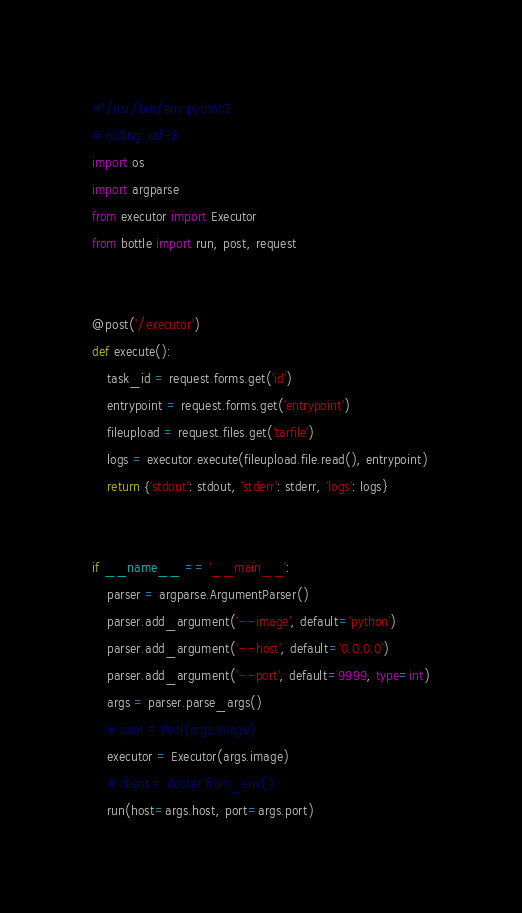Convert code to text. <code><loc_0><loc_0><loc_500><loc_500><_Python_>#!/usr/bin/env python3
# coding: utf-8
import os
import argparse
from executor import Executor
from bottle import run, post, request


@post('/executor')
def execute():
    task_id = request.forms.get('id')
    entrypoint = request.forms.get('entrypoint')
    fileupload = request.files.get('tarfile')
    logs = executor.execute(fileupload.file.read(), entrypoint)
    return {'stdout': stdout, 'stderr': stderr, 'logs': logs}


if __name__ == '__main__':
    parser = argparse.ArgumentParser()
    parser.add_argument('--image', default='python')
    parser.add_argument('--host', default='0.0.0.0')
    parser.add_argument('--port', default=9999, type=int)
    args = parser.parse_args()
    # pool = Pool(args.image)
    executor = Executor(args.image)
    # client = docker.from_env()
    run(host=args.host, port=args.port)</code> 